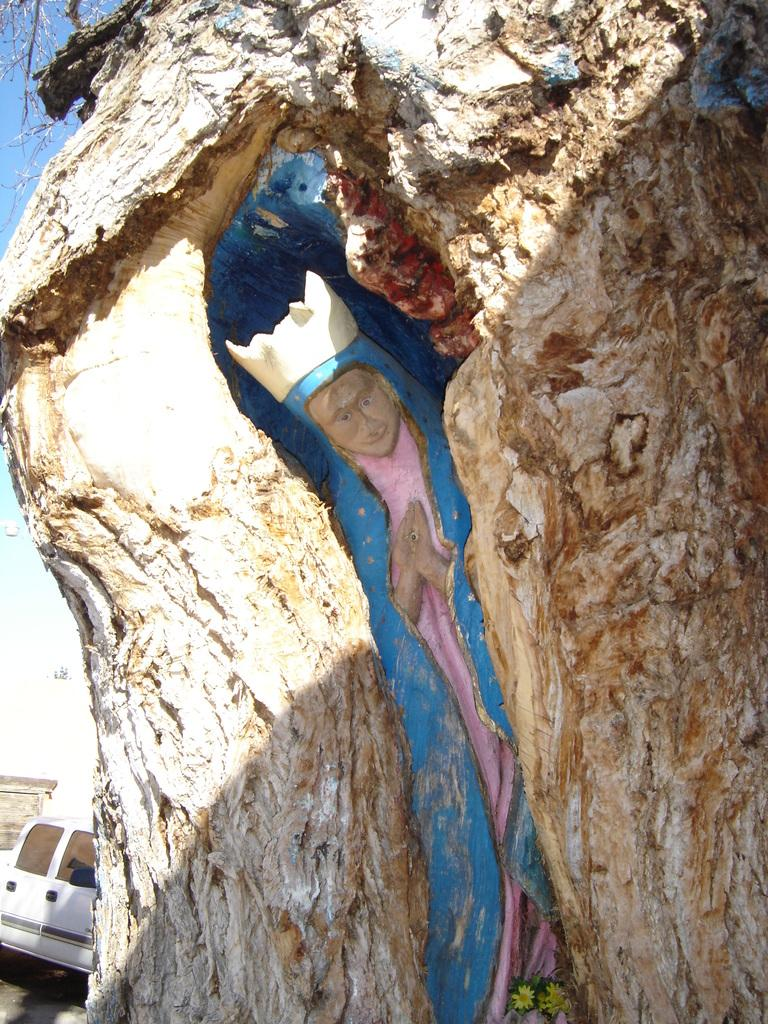What is the main subject of the image? The main subject of the image is a rock. What is on the rock? There are paintings in multiple colors on the rock. What can be seen in the background of the image? There is a white-colored vehicle in the background of the image. What color is the sky in the image? The sky is blue in the image. How much money is being cooked on the stove in the image? There is no stove or money present in the image; it features a rock with paintings and a vehicle in the background. 